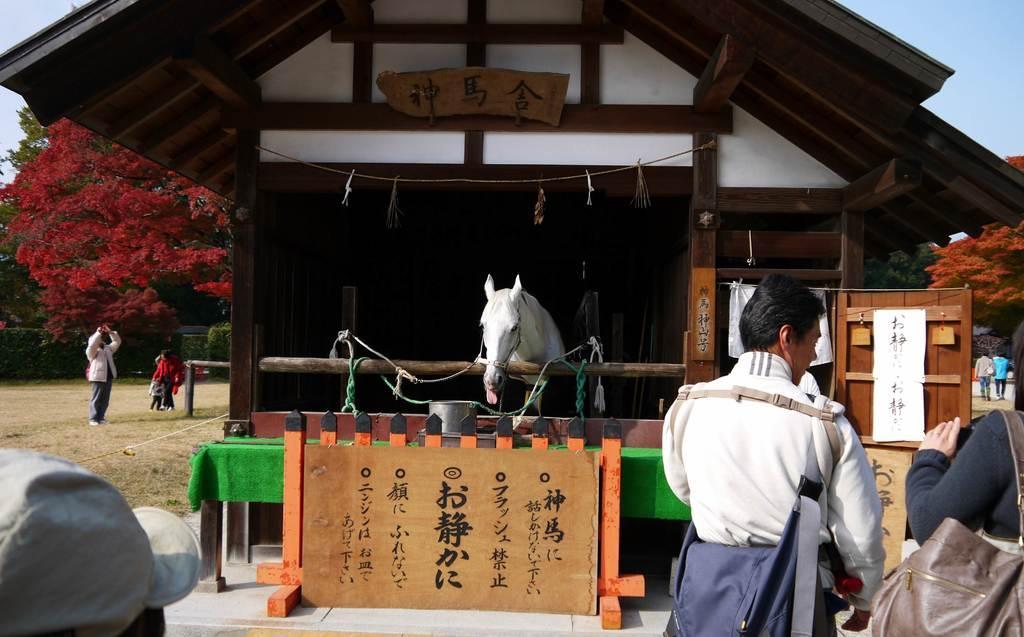Please provide a concise description of this image. In this image, I can see a group of people on the ground, boards, metal rods and a horse in a stable. In the background, I can see trees, plants and the sky. This image is taken, maybe during a day. 